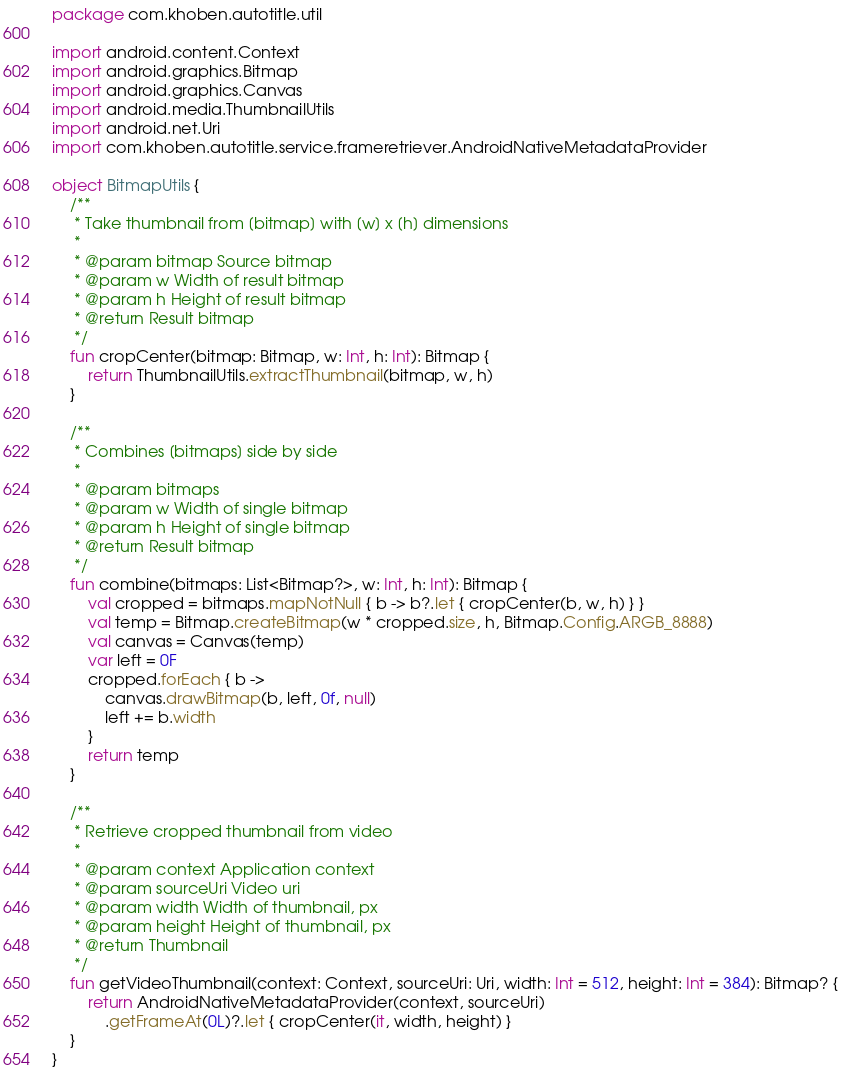Convert code to text. <code><loc_0><loc_0><loc_500><loc_500><_Kotlin_>package com.khoben.autotitle.util

import android.content.Context
import android.graphics.Bitmap
import android.graphics.Canvas
import android.media.ThumbnailUtils
import android.net.Uri
import com.khoben.autotitle.service.frameretriever.AndroidNativeMetadataProvider

object BitmapUtils {
    /**
     * Take thumbnail from [bitmap] with [w] x [h] dimensions
     *
     * @param bitmap Source bitmap
     * @param w Width of result bitmap
     * @param h Height of result bitmap
     * @return Result bitmap
     */
    fun cropCenter(bitmap: Bitmap, w: Int, h: Int): Bitmap {
        return ThumbnailUtils.extractThumbnail(bitmap, w, h)
    }

    /**
     * Combines [bitmaps] side by side
     *
     * @param bitmaps
     * @param w Width of single bitmap
     * @param h Height of single bitmap
     * @return Result bitmap
     */
    fun combine(bitmaps: List<Bitmap?>, w: Int, h: Int): Bitmap {
        val cropped = bitmaps.mapNotNull { b -> b?.let { cropCenter(b, w, h) } }
        val temp = Bitmap.createBitmap(w * cropped.size, h, Bitmap.Config.ARGB_8888)
        val canvas = Canvas(temp)
        var left = 0F
        cropped.forEach { b ->
            canvas.drawBitmap(b, left, 0f, null)
            left += b.width
        }
        return temp
    }

    /**
     * Retrieve cropped thumbnail from video
     *
     * @param context Application context
     * @param sourceUri Video uri
     * @param width Width of thumbnail, px
     * @param height Height of thumbnail, px
     * @return Thumbnail
     */
    fun getVideoThumbnail(context: Context, sourceUri: Uri, width: Int = 512, height: Int = 384): Bitmap? {
        return AndroidNativeMetadataProvider(context, sourceUri)
            .getFrameAt(0L)?.let { cropCenter(it, width, height) }
    }
}</code> 